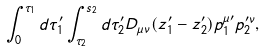<formula> <loc_0><loc_0><loc_500><loc_500>\int _ { 0 } ^ { \tau _ { 1 } } d \tau _ { 1 } ^ { \prime } \int _ { \tau _ { 2 } } ^ { s _ { 2 } } d \tau _ { 2 } ^ { \prime } D _ { \mu \nu } ( z _ { 1 } ^ { \prime } - z _ { 2 } ^ { \prime } ) p _ { 1 } ^ { \mu \prime } p _ { 2 } ^ { \prime \nu } ,</formula> 